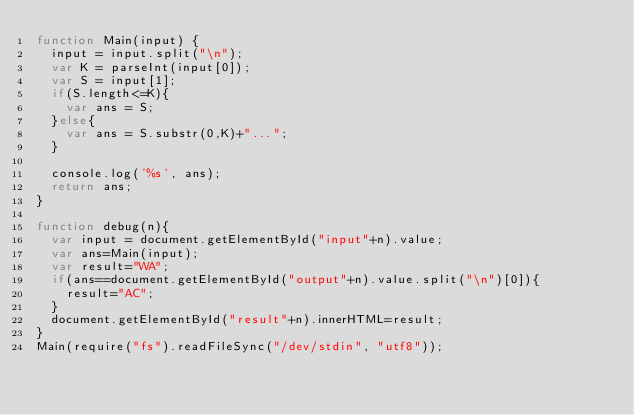Convert code to text. <code><loc_0><loc_0><loc_500><loc_500><_JavaScript_>function Main(input) {
  input = input.split("\n");
  var K = parseInt(input[0]);
  var S = input[1];
  if(S.length<=K){
    var ans = S;
  }else{
    var ans = S.substr(0,K)+"...";
  }

  console.log('%s', ans);
  return ans;
}

function debug(n){
  var input = document.getElementById("input"+n).value;
  var ans=Main(input);
  var result="WA";
  if(ans==document.getElementById("output"+n).value.split("\n")[0]){
    result="AC";
  }
  document.getElementById("result"+n).innerHTML=result;
}
Main(require("fs").readFileSync("/dev/stdin", "utf8"));</code> 